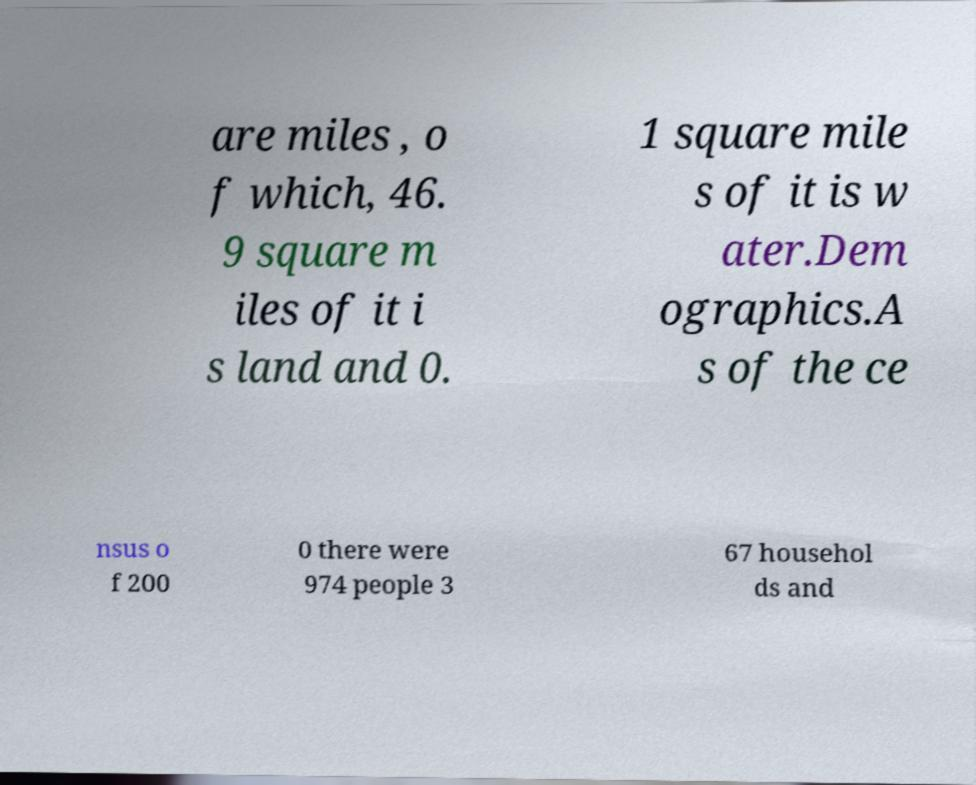Can you read and provide the text displayed in the image?This photo seems to have some interesting text. Can you extract and type it out for me? are miles , o f which, 46. 9 square m iles of it i s land and 0. 1 square mile s of it is w ater.Dem ographics.A s of the ce nsus o f 200 0 there were 974 people 3 67 househol ds and 